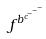<formula> <loc_0><loc_0><loc_500><loc_500>f ^ { b ^ { c ^ { - ^ { - ^ { - } } } } }</formula> 